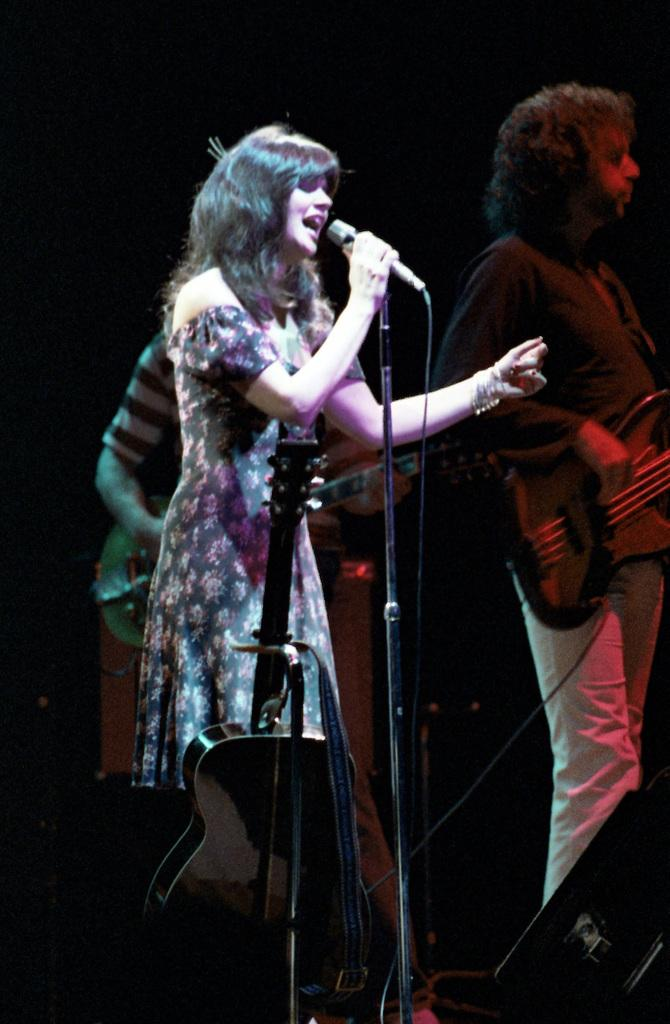How many people are in the image? There are three persons in the image. Where are the persons located in the image? The persons are standing on a stage. What are the persons doing in the image? The persons are playing musical instruments. What type of language is being spoken by the persons on the stage? There is no indication in the image of what language, if any, is being spoken by the persons on the stage. 